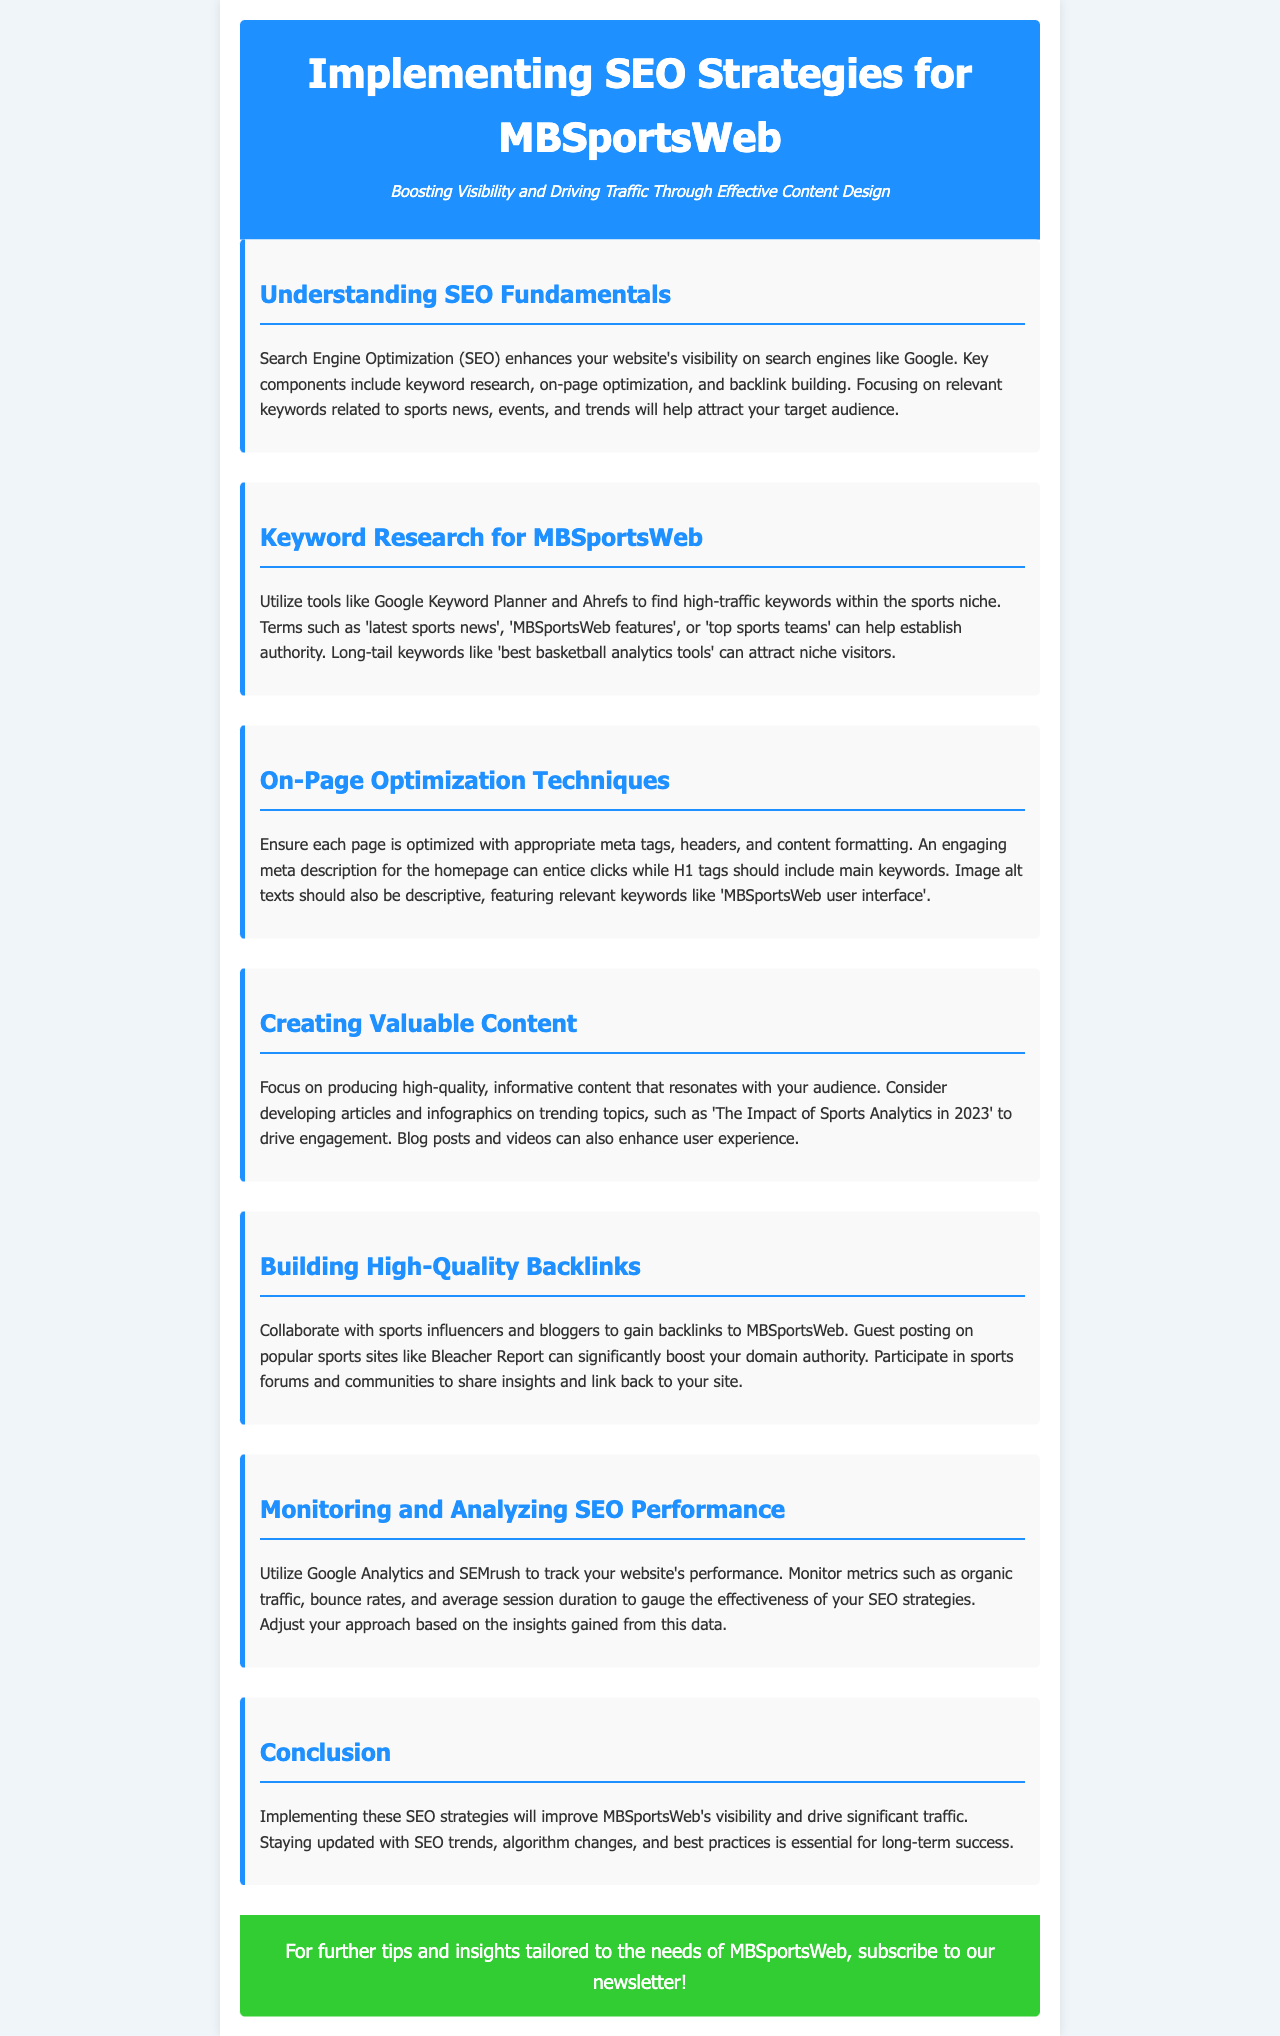What is the title of the newsletter? The title of the newsletter is the main header that informs readers about the content, which is "Implementing SEO Strategies for MBSportsWeb".
Answer: Implementing SEO Strategies for MBSportsWeb What is one key component of SEO mentioned in the document? The document lists several components of SEO, one of which is "keyword research".
Answer: keyword research Which tools are suggested for keyword research? The document mentions specific tools that are recommended for keyword research, including "Google Keyword Planner" and "Ahrefs".
Answer: Google Keyword Planner, Ahrefs What type of content does the newsletter suggest creating to drive engagement? The document advises producing specific types of content that resonate with the audience, such as "articles and infographics".
Answer: articles and infographics What should be monitored to gauge SEO performance? The document highlights the importance of tracking specific metrics to assess SEO performance, one of which is "organic traffic".
Answer: organic traffic How does the document suggest building high-quality backlinks? The document provides methods for acquiring backlinks, specifically mentioning collaboration with "sports influencers and bloggers".
Answer: sports influencers and bloggers What is the purpose of the CTA at the end of the document? The CTA’s role is to encourage readers to subscribe for additional tips and insights tailored to MBSportsWeb.
Answer: subscribe to our newsletter Which aspect of SEO does on-page optimization focus on? The document specifies that on-page optimization involves ensuring each page has appropriate "meta tags, headers, and content formatting".
Answer: meta tags, headers, and content formatting What is the impact of sports analytics discussed in the suggested content topic? The document suggests a topic centered around the impact of sports analytics, specifically mentioned as "The Impact of Sports Analytics in 2023".
Answer: The Impact of Sports Analytics in 2023 